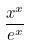Convert formula to latex. <formula><loc_0><loc_0><loc_500><loc_500>\frac { x ^ { x } } { e ^ { x } }</formula> 